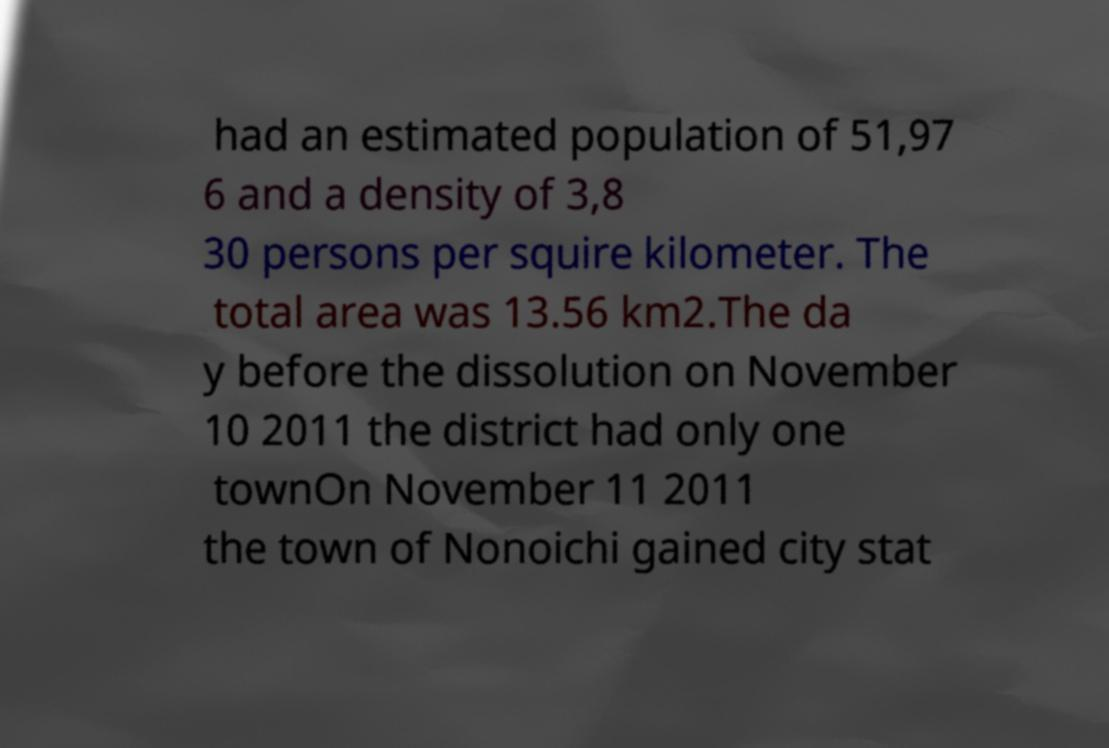For documentation purposes, I need the text within this image transcribed. Could you provide that? had an estimated population of 51,97 6 and a density of 3,8 30 persons per squire kilometer. The total area was 13.56 km2.The da y before the dissolution on November 10 2011 the district had only one townOn November 11 2011 the town of Nonoichi gained city stat 